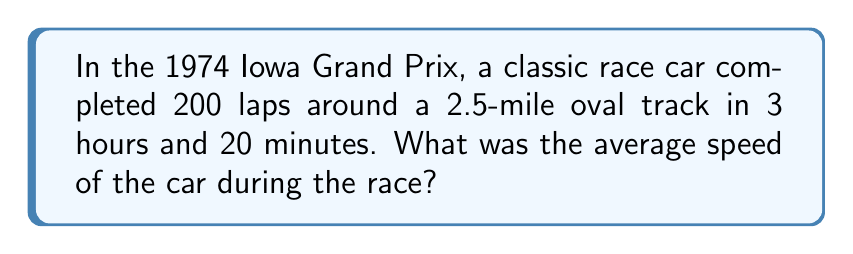Can you answer this question? Let's approach this step-by-step:

1. Calculate the total distance:
   $$\text{Total distance} = \text{Number of laps} \times \text{Track length}$$
   $$\text{Total distance} = 200 \times 2.5 = 500 \text{ miles}$$

2. Convert the time to hours:
   $$3 \text{ hours and } 20 \text{ minutes} = 3 + \frac{20}{60} = 3.333... \text{ hours}$$

3. Use the formula for average speed:
   $$\text{Average Speed} = \frac{\text{Total Distance}}{\text{Total Time}}$$

4. Plug in the values:
   $$\text{Average Speed} = \frac{500 \text{ miles}}{3.333... \text{ hours}}$$

5. Perform the division:
   $$\text{Average Speed} = 150 \text{ miles per hour}$$
Answer: 150 mph 